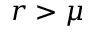Convert formula to latex. <formula><loc_0><loc_0><loc_500><loc_500>r > \mu</formula> 